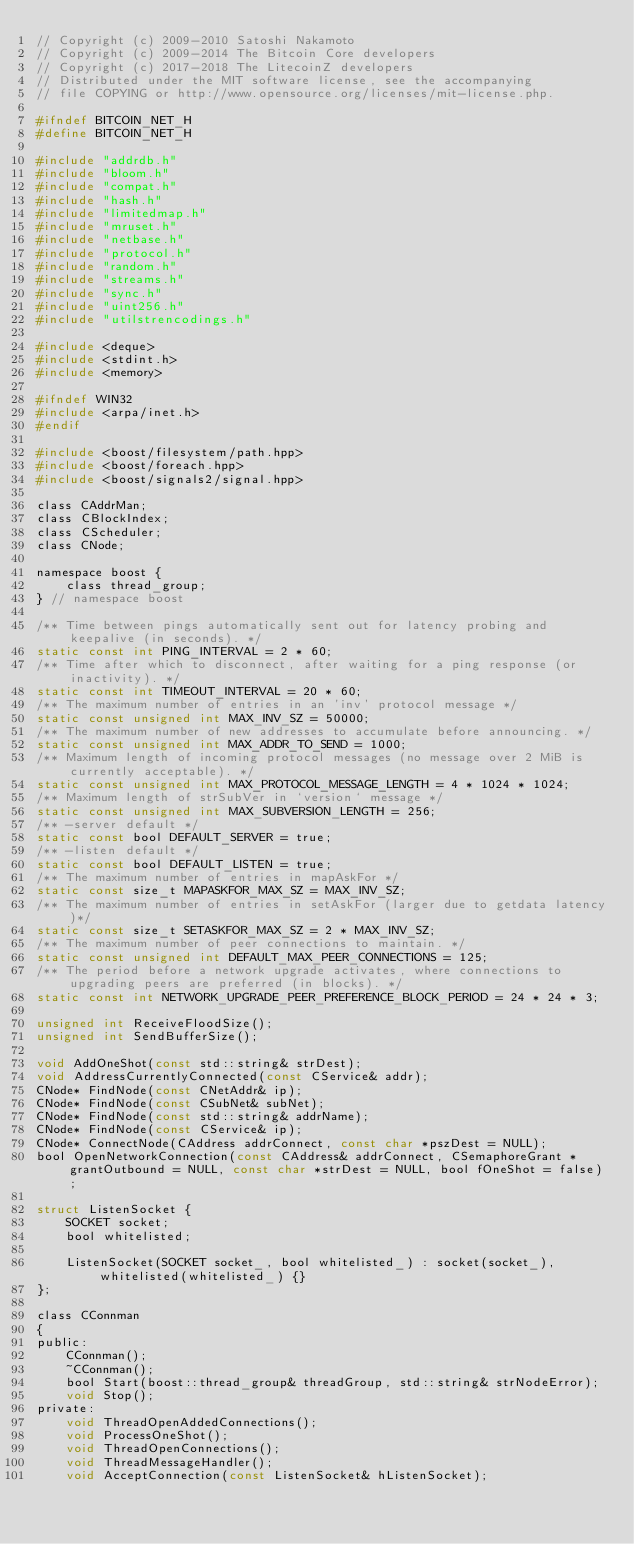Convert code to text. <code><loc_0><loc_0><loc_500><loc_500><_C_>// Copyright (c) 2009-2010 Satoshi Nakamoto
// Copyright (c) 2009-2014 The Bitcoin Core developers
// Copyright (c) 2017-2018 The LitecoinZ developers
// Distributed under the MIT software license, see the accompanying
// file COPYING or http://www.opensource.org/licenses/mit-license.php.

#ifndef BITCOIN_NET_H
#define BITCOIN_NET_H

#include "addrdb.h"
#include "bloom.h"
#include "compat.h"
#include "hash.h"
#include "limitedmap.h"
#include "mruset.h"
#include "netbase.h"
#include "protocol.h"
#include "random.h"
#include "streams.h"
#include "sync.h"
#include "uint256.h"
#include "utilstrencodings.h"

#include <deque>
#include <stdint.h>
#include <memory>

#ifndef WIN32
#include <arpa/inet.h>
#endif

#include <boost/filesystem/path.hpp>
#include <boost/foreach.hpp>
#include <boost/signals2/signal.hpp>

class CAddrMan;
class CBlockIndex;
class CScheduler;
class CNode;

namespace boost {
    class thread_group;
} // namespace boost

/** Time between pings automatically sent out for latency probing and keepalive (in seconds). */
static const int PING_INTERVAL = 2 * 60;
/** Time after which to disconnect, after waiting for a ping response (or inactivity). */
static const int TIMEOUT_INTERVAL = 20 * 60;
/** The maximum number of entries in an 'inv' protocol message */
static const unsigned int MAX_INV_SZ = 50000;
/** The maximum number of new addresses to accumulate before announcing. */
static const unsigned int MAX_ADDR_TO_SEND = 1000;
/** Maximum length of incoming protocol messages (no message over 2 MiB is currently acceptable). */
static const unsigned int MAX_PROTOCOL_MESSAGE_LENGTH = 4 * 1024 * 1024;
/** Maximum length of strSubVer in `version` message */
static const unsigned int MAX_SUBVERSION_LENGTH = 256;
/** -server default */
static const bool DEFAULT_SERVER = true;
/** -listen default */
static const bool DEFAULT_LISTEN = true;
/** The maximum number of entries in mapAskFor */
static const size_t MAPASKFOR_MAX_SZ = MAX_INV_SZ;
/** The maximum number of entries in setAskFor (larger due to getdata latency)*/
static const size_t SETASKFOR_MAX_SZ = 2 * MAX_INV_SZ;
/** The maximum number of peer connections to maintain. */
static const unsigned int DEFAULT_MAX_PEER_CONNECTIONS = 125;
/** The period before a network upgrade activates, where connections to upgrading peers are preferred (in blocks). */
static const int NETWORK_UPGRADE_PEER_PREFERENCE_BLOCK_PERIOD = 24 * 24 * 3;

unsigned int ReceiveFloodSize();
unsigned int SendBufferSize();

void AddOneShot(const std::string& strDest);
void AddressCurrentlyConnected(const CService& addr);
CNode* FindNode(const CNetAddr& ip);
CNode* FindNode(const CSubNet& subNet);
CNode* FindNode(const std::string& addrName);
CNode* FindNode(const CService& ip);
CNode* ConnectNode(CAddress addrConnect, const char *pszDest = NULL);
bool OpenNetworkConnection(const CAddress& addrConnect, CSemaphoreGrant *grantOutbound = NULL, const char *strDest = NULL, bool fOneShot = false);

struct ListenSocket {
    SOCKET socket;
    bool whitelisted;

    ListenSocket(SOCKET socket_, bool whitelisted_) : socket(socket_), whitelisted(whitelisted_) {}
};

class CConnman
{
public:
    CConnman();
    ~CConnman();
    bool Start(boost::thread_group& threadGroup, std::string& strNodeError);
    void Stop();
private:
    void ThreadOpenAddedConnections();
    void ProcessOneShot();
    void ThreadOpenConnections();
    void ThreadMessageHandler();
    void AcceptConnection(const ListenSocket& hListenSocket);</code> 